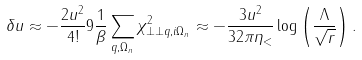<formula> <loc_0><loc_0><loc_500><loc_500>\delta u \approx - \frac { 2 u ^ { 2 } } { 4 ! } 9 \frac { 1 } { \beta } \sum _ { { q } , \Omega _ { n } } \chi ^ { 2 } _ { \perp \perp { q } , i \Omega _ { n } } \approx - \frac { 3 u ^ { 2 } } { 3 2 \pi \eta _ { < } } \log \left ( \frac { \Lambda } { \sqrt { r } } \right ) .</formula> 